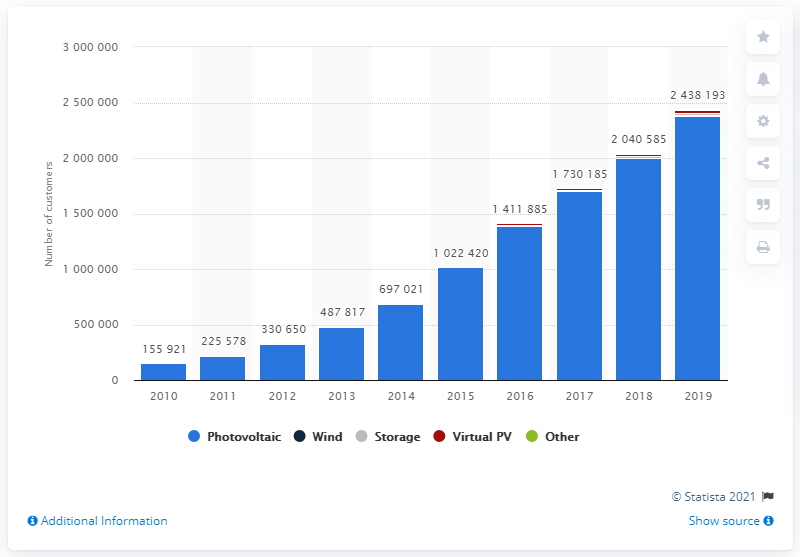List a handful of essential elements in this visual. As of 2019, the total number of net metering customers in the United States was approximately 237,675,300. 